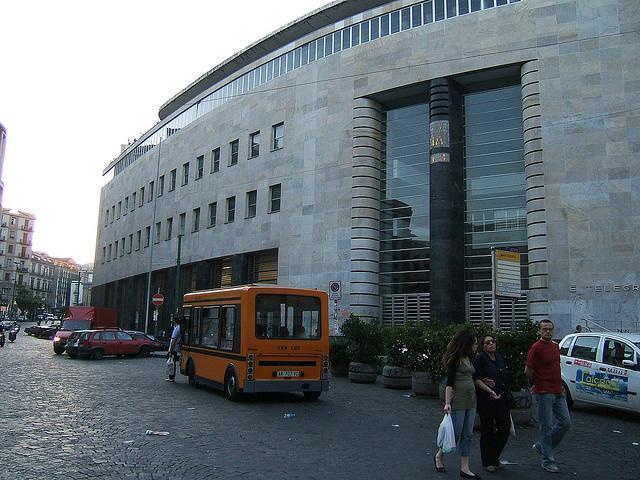How many people are wearing hats?
Give a very brief answer. 0. How many people can you see?
Give a very brief answer. 3. How many potted plants are there?
Give a very brief answer. 2. 